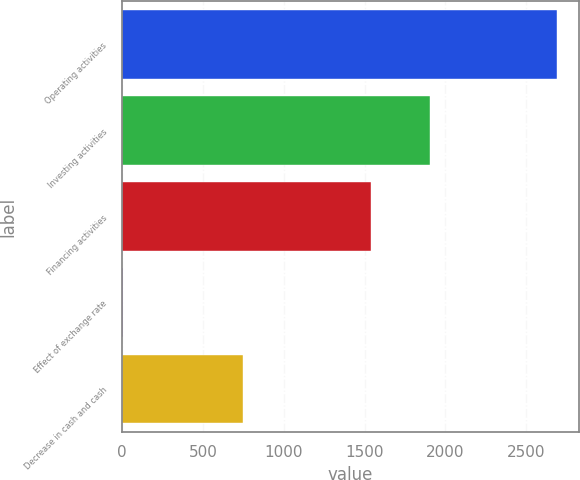Convert chart to OTSL. <chart><loc_0><loc_0><loc_500><loc_500><bar_chart><fcel>Operating activities<fcel>Investing activities<fcel>Financing activities<fcel>Effect of exchange rate<fcel>Decrease in cash and cash<nl><fcel>2691<fcel>1904<fcel>1542<fcel>5<fcel>750<nl></chart> 